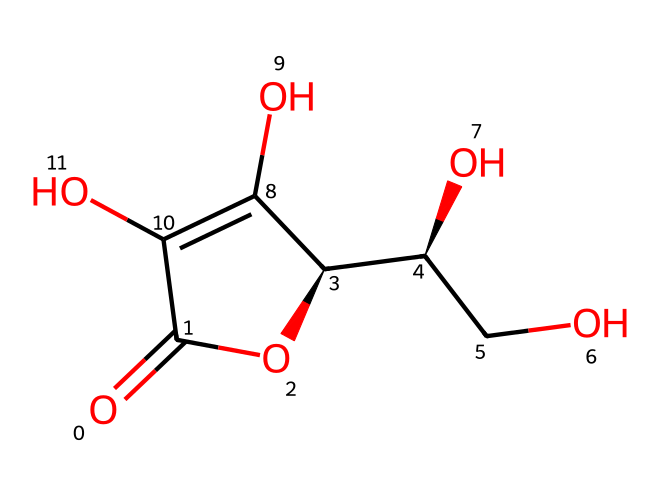What is the molecular formula of the compound represented by this SMILES? By interpreting the SMILES structure, we identify the atoms present: there are 6 carbon atoms, 8 hydrogen atoms, and 6 oxygen atoms in the compound. The molecular formula is derived by counting each type of atom.
Answer: C6H8O6 How many rings are present in the structure? The SMILES indicates a cyclic structure (C1), which means there is one ring in the compound. After analyzing the structure, we find that no additional ring is present.
Answer: 1 What type of functional groups are present in this compound? The structure has hydroxyl (–OH) groups and a carbonyl (C=O) group. The presence of multiple –OH groups indicates that it is a polyol. Analyzing the functional groups gives a clear picture of its properties.
Answer: hydroxyl, carbonyl What is the stereochemistry at the chiral centers? The structure contains two chiral centers (C@H) indicated by the '@' symbol. To understand their stereochemistry, we can locate the chiral carbons and analyze the substituents around them. This reveals their specific spatial arrangement.
Answer: two chiral centers How does this compound function as an antioxidant? The molecular structure has hydroxyl groups that can donate electrons and neutralize free radicals, which is a key mechanism for its antioxidant activity. Understanding the electron donation capability of the –OH groups helps in linking the structure to its function.
Answer: electron donor What distinguishing feature of this compound contributes to its acidity? The presence of the carbonyl group (C=O) adjacent to hydroxyl groups (–OH) indicates that it can release protons (H+), contributing to acidity. Evaluating the arrangement of these groups clarifies why the compound behaves as an acid.
Answer: carbonyl group 